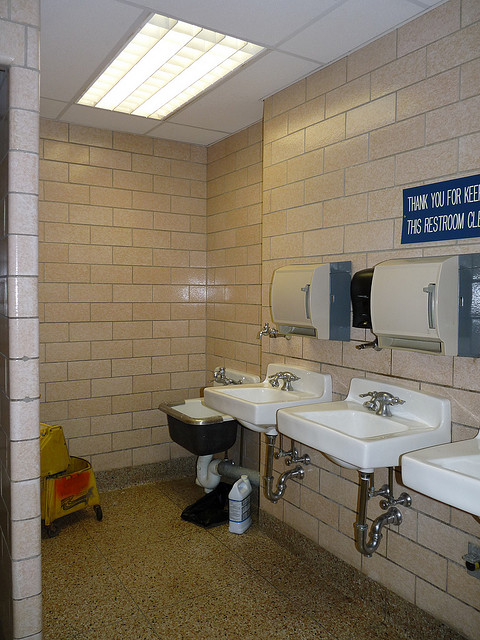Is this restroom accessible for the disabled? The restroom shown seems to follow accessibility guidelines with sufficient space, though it lacks visible grab bars, which are critical for full accessibility. 